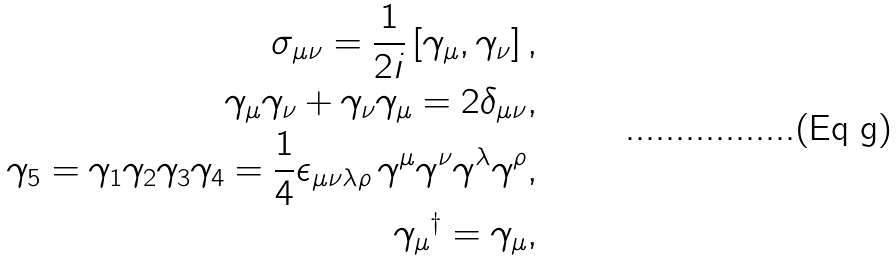Convert formula to latex. <formula><loc_0><loc_0><loc_500><loc_500>\sigma _ { \mu \nu } = \frac { 1 } { 2 i } \left [ \gamma _ { \mu } , \gamma _ { \nu } \right ] , \\ \gamma _ { \mu } \gamma _ { \nu } + \gamma _ { \nu } \gamma _ { \mu } = 2 \delta _ { \mu \nu } , \\ \gamma _ { 5 } = \gamma _ { 1 } \gamma _ { 2 } \gamma _ { 3 } \gamma _ { 4 } = \frac { 1 } { 4 } \epsilon _ { \mu \nu \lambda \rho } \, \gamma ^ { \mu } \gamma ^ { \nu } \gamma ^ { \lambda } \gamma ^ { \rho } , \\ { \gamma _ { \mu } } ^ { \dag } = \gamma _ { \mu } ,</formula> 